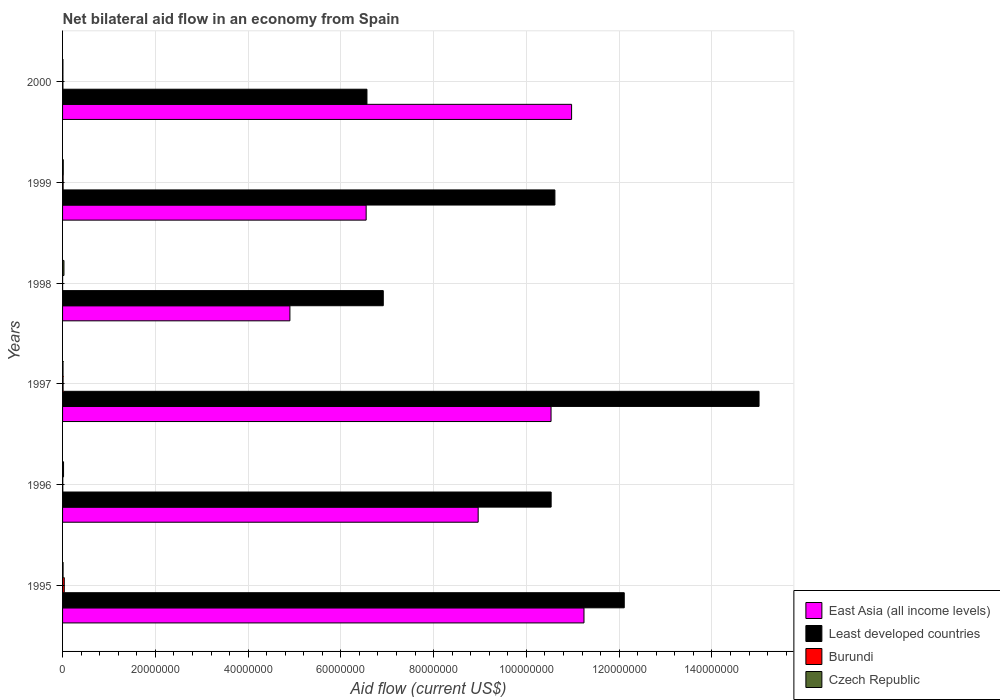How many different coloured bars are there?
Make the answer very short. 4. How many groups of bars are there?
Ensure brevity in your answer.  6. Are the number of bars per tick equal to the number of legend labels?
Make the answer very short. Yes. Are the number of bars on each tick of the Y-axis equal?
Offer a very short reply. Yes. How many bars are there on the 6th tick from the top?
Offer a very short reply. 4. How many bars are there on the 4th tick from the bottom?
Your answer should be compact. 4. In how many cases, is the number of bars for a given year not equal to the number of legend labels?
Make the answer very short. 0. What is the net bilateral aid flow in Burundi in 1996?
Your answer should be very brief. 5.00e+04. Across all years, what is the maximum net bilateral aid flow in East Asia (all income levels)?
Provide a short and direct response. 1.12e+08. In which year was the net bilateral aid flow in Czech Republic minimum?
Make the answer very short. 2000. What is the total net bilateral aid flow in Czech Republic in the graph?
Ensure brevity in your answer.  9.50e+05. What is the difference between the net bilateral aid flow in Czech Republic in 1996 and that in 1997?
Keep it short and to the point. 1.10e+05. What is the difference between the net bilateral aid flow in East Asia (all income levels) in 2000 and the net bilateral aid flow in Burundi in 1995?
Provide a succinct answer. 1.09e+08. What is the average net bilateral aid flow in East Asia (all income levels) per year?
Provide a short and direct response. 8.86e+07. In the year 1999, what is the difference between the net bilateral aid flow in Least developed countries and net bilateral aid flow in Czech Republic?
Provide a short and direct response. 1.06e+08. In how many years, is the net bilateral aid flow in Burundi greater than 124000000 US$?
Offer a terse response. 0. What is the ratio of the net bilateral aid flow in Least developed countries in 1995 to that in 1996?
Your answer should be very brief. 1.15. Is the net bilateral aid flow in Burundi in 1996 less than that in 1997?
Make the answer very short. Yes. Is the difference between the net bilateral aid flow in Least developed countries in 1995 and 2000 greater than the difference between the net bilateral aid flow in Czech Republic in 1995 and 2000?
Offer a very short reply. Yes. What is the difference between the highest and the second highest net bilateral aid flow in East Asia (all income levels)?
Your answer should be compact. 2.67e+06. What is the difference between the highest and the lowest net bilateral aid flow in Burundi?
Your response must be concise. 3.60e+05. In how many years, is the net bilateral aid flow in Least developed countries greater than the average net bilateral aid flow in Least developed countries taken over all years?
Make the answer very short. 4. Is the sum of the net bilateral aid flow in Burundi in 1997 and 1999 greater than the maximum net bilateral aid flow in East Asia (all income levels) across all years?
Provide a short and direct response. No. What does the 1st bar from the top in 1997 represents?
Provide a short and direct response. Czech Republic. What does the 2nd bar from the bottom in 1999 represents?
Offer a terse response. Least developed countries. How many years are there in the graph?
Give a very brief answer. 6. What is the difference between two consecutive major ticks on the X-axis?
Your answer should be very brief. 2.00e+07. Where does the legend appear in the graph?
Provide a short and direct response. Bottom right. How many legend labels are there?
Provide a succinct answer. 4. What is the title of the graph?
Your answer should be compact. Net bilateral aid flow in an economy from Spain. What is the label or title of the Y-axis?
Ensure brevity in your answer.  Years. What is the Aid flow (current US$) in East Asia (all income levels) in 1995?
Give a very brief answer. 1.12e+08. What is the Aid flow (current US$) of Least developed countries in 1995?
Make the answer very short. 1.21e+08. What is the Aid flow (current US$) in Burundi in 1995?
Offer a very short reply. 3.70e+05. What is the Aid flow (current US$) in East Asia (all income levels) in 1996?
Give a very brief answer. 8.96e+07. What is the Aid flow (current US$) of Least developed countries in 1996?
Offer a very short reply. 1.05e+08. What is the Aid flow (current US$) in Burundi in 1996?
Provide a short and direct response. 5.00e+04. What is the Aid flow (current US$) in East Asia (all income levels) in 1997?
Your response must be concise. 1.05e+08. What is the Aid flow (current US$) in Least developed countries in 1997?
Provide a short and direct response. 1.50e+08. What is the Aid flow (current US$) in Czech Republic in 1997?
Provide a short and direct response. 1.00e+05. What is the Aid flow (current US$) of East Asia (all income levels) in 1998?
Your response must be concise. 4.90e+07. What is the Aid flow (current US$) in Least developed countries in 1998?
Your response must be concise. 6.91e+07. What is the Aid flow (current US$) of Burundi in 1998?
Your answer should be very brief. 10000. What is the Aid flow (current US$) in Czech Republic in 1998?
Offer a very short reply. 3.00e+05. What is the Aid flow (current US$) of East Asia (all income levels) in 1999?
Offer a very short reply. 6.54e+07. What is the Aid flow (current US$) in Least developed countries in 1999?
Your answer should be compact. 1.06e+08. What is the Aid flow (current US$) of East Asia (all income levels) in 2000?
Give a very brief answer. 1.10e+08. What is the Aid flow (current US$) of Least developed countries in 2000?
Keep it short and to the point. 6.56e+07. Across all years, what is the maximum Aid flow (current US$) in East Asia (all income levels)?
Your answer should be compact. 1.12e+08. Across all years, what is the maximum Aid flow (current US$) in Least developed countries?
Your answer should be compact. 1.50e+08. Across all years, what is the maximum Aid flow (current US$) of Czech Republic?
Provide a succinct answer. 3.00e+05. Across all years, what is the minimum Aid flow (current US$) in East Asia (all income levels)?
Your answer should be very brief. 4.90e+07. Across all years, what is the minimum Aid flow (current US$) of Least developed countries?
Give a very brief answer. 6.56e+07. Across all years, what is the minimum Aid flow (current US$) in Czech Republic?
Provide a succinct answer. 8.00e+04. What is the total Aid flow (current US$) of East Asia (all income levels) in the graph?
Make the answer very short. 5.32e+08. What is the total Aid flow (current US$) of Least developed countries in the graph?
Provide a short and direct response. 6.17e+08. What is the total Aid flow (current US$) of Burundi in the graph?
Give a very brief answer. 7.40e+05. What is the total Aid flow (current US$) in Czech Republic in the graph?
Give a very brief answer. 9.50e+05. What is the difference between the Aid flow (current US$) of East Asia (all income levels) in 1995 and that in 1996?
Give a very brief answer. 2.28e+07. What is the difference between the Aid flow (current US$) in Least developed countries in 1995 and that in 1996?
Give a very brief answer. 1.58e+07. What is the difference between the Aid flow (current US$) of Burundi in 1995 and that in 1996?
Make the answer very short. 3.20e+05. What is the difference between the Aid flow (current US$) of Czech Republic in 1995 and that in 1996?
Make the answer very short. -1.00e+05. What is the difference between the Aid flow (current US$) in East Asia (all income levels) in 1995 and that in 1997?
Ensure brevity in your answer.  7.10e+06. What is the difference between the Aid flow (current US$) in Least developed countries in 1995 and that in 1997?
Offer a terse response. -2.91e+07. What is the difference between the Aid flow (current US$) in Czech Republic in 1995 and that in 1997?
Your answer should be compact. 10000. What is the difference between the Aid flow (current US$) in East Asia (all income levels) in 1995 and that in 1998?
Your answer should be compact. 6.34e+07. What is the difference between the Aid flow (current US$) of Least developed countries in 1995 and that in 1998?
Your answer should be very brief. 5.20e+07. What is the difference between the Aid flow (current US$) in Burundi in 1995 and that in 1998?
Provide a succinct answer. 3.60e+05. What is the difference between the Aid flow (current US$) of Czech Republic in 1995 and that in 1998?
Give a very brief answer. -1.90e+05. What is the difference between the Aid flow (current US$) in East Asia (all income levels) in 1995 and that in 1999?
Make the answer very short. 4.70e+07. What is the difference between the Aid flow (current US$) in Least developed countries in 1995 and that in 1999?
Offer a very short reply. 1.50e+07. What is the difference between the Aid flow (current US$) of Burundi in 1995 and that in 1999?
Provide a short and direct response. 2.50e+05. What is the difference between the Aid flow (current US$) in East Asia (all income levels) in 1995 and that in 2000?
Give a very brief answer. 2.67e+06. What is the difference between the Aid flow (current US$) in Least developed countries in 1995 and that in 2000?
Offer a terse response. 5.55e+07. What is the difference between the Aid flow (current US$) in Burundi in 1995 and that in 2000?
Provide a short and direct response. 2.90e+05. What is the difference between the Aid flow (current US$) in East Asia (all income levels) in 1996 and that in 1997?
Offer a very short reply. -1.57e+07. What is the difference between the Aid flow (current US$) in Least developed countries in 1996 and that in 1997?
Offer a very short reply. -4.48e+07. What is the difference between the Aid flow (current US$) of Burundi in 1996 and that in 1997?
Offer a terse response. -6.00e+04. What is the difference between the Aid flow (current US$) in East Asia (all income levels) in 1996 and that in 1998?
Offer a terse response. 4.06e+07. What is the difference between the Aid flow (current US$) in Least developed countries in 1996 and that in 1998?
Your response must be concise. 3.62e+07. What is the difference between the Aid flow (current US$) of Czech Republic in 1996 and that in 1998?
Provide a short and direct response. -9.00e+04. What is the difference between the Aid flow (current US$) in East Asia (all income levels) in 1996 and that in 1999?
Your answer should be very brief. 2.42e+07. What is the difference between the Aid flow (current US$) in Least developed countries in 1996 and that in 1999?
Your answer should be compact. -8.10e+05. What is the difference between the Aid flow (current US$) in Czech Republic in 1996 and that in 1999?
Offer a very short reply. 6.00e+04. What is the difference between the Aid flow (current US$) of East Asia (all income levels) in 1996 and that in 2000?
Make the answer very short. -2.01e+07. What is the difference between the Aid flow (current US$) of Least developed countries in 1996 and that in 2000?
Keep it short and to the point. 3.97e+07. What is the difference between the Aid flow (current US$) in Burundi in 1996 and that in 2000?
Give a very brief answer. -3.00e+04. What is the difference between the Aid flow (current US$) of Czech Republic in 1996 and that in 2000?
Your answer should be very brief. 1.30e+05. What is the difference between the Aid flow (current US$) of East Asia (all income levels) in 1997 and that in 1998?
Give a very brief answer. 5.63e+07. What is the difference between the Aid flow (current US$) of Least developed countries in 1997 and that in 1998?
Your answer should be compact. 8.10e+07. What is the difference between the Aid flow (current US$) of East Asia (all income levels) in 1997 and that in 1999?
Make the answer very short. 3.99e+07. What is the difference between the Aid flow (current US$) in Least developed countries in 1997 and that in 1999?
Offer a very short reply. 4.40e+07. What is the difference between the Aid flow (current US$) in Burundi in 1997 and that in 1999?
Your response must be concise. -10000. What is the difference between the Aid flow (current US$) in East Asia (all income levels) in 1997 and that in 2000?
Give a very brief answer. -4.43e+06. What is the difference between the Aid flow (current US$) of Least developed countries in 1997 and that in 2000?
Your answer should be compact. 8.45e+07. What is the difference between the Aid flow (current US$) of Burundi in 1997 and that in 2000?
Offer a terse response. 3.00e+04. What is the difference between the Aid flow (current US$) in East Asia (all income levels) in 1998 and that in 1999?
Make the answer very short. -1.64e+07. What is the difference between the Aid flow (current US$) of Least developed countries in 1998 and that in 1999?
Your response must be concise. -3.70e+07. What is the difference between the Aid flow (current US$) in Czech Republic in 1998 and that in 1999?
Your response must be concise. 1.50e+05. What is the difference between the Aid flow (current US$) in East Asia (all income levels) in 1998 and that in 2000?
Ensure brevity in your answer.  -6.07e+07. What is the difference between the Aid flow (current US$) of Least developed countries in 1998 and that in 2000?
Offer a terse response. 3.52e+06. What is the difference between the Aid flow (current US$) of Burundi in 1998 and that in 2000?
Your response must be concise. -7.00e+04. What is the difference between the Aid flow (current US$) in East Asia (all income levels) in 1999 and that in 2000?
Offer a very short reply. -4.43e+07. What is the difference between the Aid flow (current US$) in Least developed countries in 1999 and that in 2000?
Offer a terse response. 4.05e+07. What is the difference between the Aid flow (current US$) in Burundi in 1999 and that in 2000?
Ensure brevity in your answer.  4.00e+04. What is the difference between the Aid flow (current US$) of East Asia (all income levels) in 1995 and the Aid flow (current US$) of Least developed countries in 1996?
Your answer should be compact. 7.08e+06. What is the difference between the Aid flow (current US$) of East Asia (all income levels) in 1995 and the Aid flow (current US$) of Burundi in 1996?
Give a very brief answer. 1.12e+08. What is the difference between the Aid flow (current US$) of East Asia (all income levels) in 1995 and the Aid flow (current US$) of Czech Republic in 1996?
Ensure brevity in your answer.  1.12e+08. What is the difference between the Aid flow (current US$) of Least developed countries in 1995 and the Aid flow (current US$) of Burundi in 1996?
Provide a succinct answer. 1.21e+08. What is the difference between the Aid flow (current US$) of Least developed countries in 1995 and the Aid flow (current US$) of Czech Republic in 1996?
Provide a short and direct response. 1.21e+08. What is the difference between the Aid flow (current US$) of East Asia (all income levels) in 1995 and the Aid flow (current US$) of Least developed countries in 1997?
Keep it short and to the point. -3.77e+07. What is the difference between the Aid flow (current US$) in East Asia (all income levels) in 1995 and the Aid flow (current US$) in Burundi in 1997?
Your response must be concise. 1.12e+08. What is the difference between the Aid flow (current US$) in East Asia (all income levels) in 1995 and the Aid flow (current US$) in Czech Republic in 1997?
Give a very brief answer. 1.12e+08. What is the difference between the Aid flow (current US$) of Least developed countries in 1995 and the Aid flow (current US$) of Burundi in 1997?
Provide a succinct answer. 1.21e+08. What is the difference between the Aid flow (current US$) of Least developed countries in 1995 and the Aid flow (current US$) of Czech Republic in 1997?
Offer a terse response. 1.21e+08. What is the difference between the Aid flow (current US$) of East Asia (all income levels) in 1995 and the Aid flow (current US$) of Least developed countries in 1998?
Ensure brevity in your answer.  4.33e+07. What is the difference between the Aid flow (current US$) in East Asia (all income levels) in 1995 and the Aid flow (current US$) in Burundi in 1998?
Offer a terse response. 1.12e+08. What is the difference between the Aid flow (current US$) in East Asia (all income levels) in 1995 and the Aid flow (current US$) in Czech Republic in 1998?
Provide a succinct answer. 1.12e+08. What is the difference between the Aid flow (current US$) of Least developed countries in 1995 and the Aid flow (current US$) of Burundi in 1998?
Make the answer very short. 1.21e+08. What is the difference between the Aid flow (current US$) of Least developed countries in 1995 and the Aid flow (current US$) of Czech Republic in 1998?
Provide a succinct answer. 1.21e+08. What is the difference between the Aid flow (current US$) of Burundi in 1995 and the Aid flow (current US$) of Czech Republic in 1998?
Provide a succinct answer. 7.00e+04. What is the difference between the Aid flow (current US$) in East Asia (all income levels) in 1995 and the Aid flow (current US$) in Least developed countries in 1999?
Your answer should be compact. 6.27e+06. What is the difference between the Aid flow (current US$) in East Asia (all income levels) in 1995 and the Aid flow (current US$) in Burundi in 1999?
Offer a terse response. 1.12e+08. What is the difference between the Aid flow (current US$) in East Asia (all income levels) in 1995 and the Aid flow (current US$) in Czech Republic in 1999?
Keep it short and to the point. 1.12e+08. What is the difference between the Aid flow (current US$) of Least developed countries in 1995 and the Aid flow (current US$) of Burundi in 1999?
Make the answer very short. 1.21e+08. What is the difference between the Aid flow (current US$) of Least developed countries in 1995 and the Aid flow (current US$) of Czech Republic in 1999?
Keep it short and to the point. 1.21e+08. What is the difference between the Aid flow (current US$) of East Asia (all income levels) in 1995 and the Aid flow (current US$) of Least developed countries in 2000?
Your answer should be very brief. 4.68e+07. What is the difference between the Aid flow (current US$) of East Asia (all income levels) in 1995 and the Aid flow (current US$) of Burundi in 2000?
Ensure brevity in your answer.  1.12e+08. What is the difference between the Aid flow (current US$) of East Asia (all income levels) in 1995 and the Aid flow (current US$) of Czech Republic in 2000?
Your answer should be very brief. 1.12e+08. What is the difference between the Aid flow (current US$) of Least developed countries in 1995 and the Aid flow (current US$) of Burundi in 2000?
Make the answer very short. 1.21e+08. What is the difference between the Aid flow (current US$) of Least developed countries in 1995 and the Aid flow (current US$) of Czech Republic in 2000?
Your response must be concise. 1.21e+08. What is the difference between the Aid flow (current US$) in Burundi in 1995 and the Aid flow (current US$) in Czech Republic in 2000?
Your answer should be compact. 2.90e+05. What is the difference between the Aid flow (current US$) of East Asia (all income levels) in 1996 and the Aid flow (current US$) of Least developed countries in 1997?
Your answer should be very brief. -6.06e+07. What is the difference between the Aid flow (current US$) in East Asia (all income levels) in 1996 and the Aid flow (current US$) in Burundi in 1997?
Ensure brevity in your answer.  8.95e+07. What is the difference between the Aid flow (current US$) of East Asia (all income levels) in 1996 and the Aid flow (current US$) of Czech Republic in 1997?
Keep it short and to the point. 8.95e+07. What is the difference between the Aid flow (current US$) of Least developed countries in 1996 and the Aid flow (current US$) of Burundi in 1997?
Offer a terse response. 1.05e+08. What is the difference between the Aid flow (current US$) in Least developed countries in 1996 and the Aid flow (current US$) in Czech Republic in 1997?
Provide a succinct answer. 1.05e+08. What is the difference between the Aid flow (current US$) in Burundi in 1996 and the Aid flow (current US$) in Czech Republic in 1997?
Provide a succinct answer. -5.00e+04. What is the difference between the Aid flow (current US$) of East Asia (all income levels) in 1996 and the Aid flow (current US$) of Least developed countries in 1998?
Give a very brief answer. 2.05e+07. What is the difference between the Aid flow (current US$) in East Asia (all income levels) in 1996 and the Aid flow (current US$) in Burundi in 1998?
Make the answer very short. 8.96e+07. What is the difference between the Aid flow (current US$) in East Asia (all income levels) in 1996 and the Aid flow (current US$) in Czech Republic in 1998?
Ensure brevity in your answer.  8.93e+07. What is the difference between the Aid flow (current US$) of Least developed countries in 1996 and the Aid flow (current US$) of Burundi in 1998?
Your response must be concise. 1.05e+08. What is the difference between the Aid flow (current US$) in Least developed countries in 1996 and the Aid flow (current US$) in Czech Republic in 1998?
Ensure brevity in your answer.  1.05e+08. What is the difference between the Aid flow (current US$) of East Asia (all income levels) in 1996 and the Aid flow (current US$) of Least developed countries in 1999?
Provide a short and direct response. -1.65e+07. What is the difference between the Aid flow (current US$) in East Asia (all income levels) in 1996 and the Aid flow (current US$) in Burundi in 1999?
Keep it short and to the point. 8.95e+07. What is the difference between the Aid flow (current US$) of East Asia (all income levels) in 1996 and the Aid flow (current US$) of Czech Republic in 1999?
Make the answer very short. 8.94e+07. What is the difference between the Aid flow (current US$) of Least developed countries in 1996 and the Aid flow (current US$) of Burundi in 1999?
Your answer should be compact. 1.05e+08. What is the difference between the Aid flow (current US$) of Least developed countries in 1996 and the Aid flow (current US$) of Czech Republic in 1999?
Give a very brief answer. 1.05e+08. What is the difference between the Aid flow (current US$) in Burundi in 1996 and the Aid flow (current US$) in Czech Republic in 1999?
Give a very brief answer. -1.00e+05. What is the difference between the Aid flow (current US$) in East Asia (all income levels) in 1996 and the Aid flow (current US$) in Least developed countries in 2000?
Keep it short and to the point. 2.40e+07. What is the difference between the Aid flow (current US$) in East Asia (all income levels) in 1996 and the Aid flow (current US$) in Burundi in 2000?
Your response must be concise. 8.95e+07. What is the difference between the Aid flow (current US$) in East Asia (all income levels) in 1996 and the Aid flow (current US$) in Czech Republic in 2000?
Provide a short and direct response. 8.95e+07. What is the difference between the Aid flow (current US$) of Least developed countries in 1996 and the Aid flow (current US$) of Burundi in 2000?
Your response must be concise. 1.05e+08. What is the difference between the Aid flow (current US$) of Least developed countries in 1996 and the Aid flow (current US$) of Czech Republic in 2000?
Give a very brief answer. 1.05e+08. What is the difference between the Aid flow (current US$) in Burundi in 1996 and the Aid flow (current US$) in Czech Republic in 2000?
Ensure brevity in your answer.  -3.00e+04. What is the difference between the Aid flow (current US$) of East Asia (all income levels) in 1997 and the Aid flow (current US$) of Least developed countries in 1998?
Offer a very short reply. 3.62e+07. What is the difference between the Aid flow (current US$) of East Asia (all income levels) in 1997 and the Aid flow (current US$) of Burundi in 1998?
Offer a terse response. 1.05e+08. What is the difference between the Aid flow (current US$) in East Asia (all income levels) in 1997 and the Aid flow (current US$) in Czech Republic in 1998?
Offer a terse response. 1.05e+08. What is the difference between the Aid flow (current US$) of Least developed countries in 1997 and the Aid flow (current US$) of Burundi in 1998?
Provide a short and direct response. 1.50e+08. What is the difference between the Aid flow (current US$) of Least developed countries in 1997 and the Aid flow (current US$) of Czech Republic in 1998?
Ensure brevity in your answer.  1.50e+08. What is the difference between the Aid flow (current US$) of East Asia (all income levels) in 1997 and the Aid flow (current US$) of Least developed countries in 1999?
Your response must be concise. -8.30e+05. What is the difference between the Aid flow (current US$) of East Asia (all income levels) in 1997 and the Aid flow (current US$) of Burundi in 1999?
Make the answer very short. 1.05e+08. What is the difference between the Aid flow (current US$) in East Asia (all income levels) in 1997 and the Aid flow (current US$) in Czech Republic in 1999?
Your response must be concise. 1.05e+08. What is the difference between the Aid flow (current US$) in Least developed countries in 1997 and the Aid flow (current US$) in Burundi in 1999?
Ensure brevity in your answer.  1.50e+08. What is the difference between the Aid flow (current US$) in Least developed countries in 1997 and the Aid flow (current US$) in Czech Republic in 1999?
Make the answer very short. 1.50e+08. What is the difference between the Aid flow (current US$) in East Asia (all income levels) in 1997 and the Aid flow (current US$) in Least developed countries in 2000?
Give a very brief answer. 3.97e+07. What is the difference between the Aid flow (current US$) of East Asia (all income levels) in 1997 and the Aid flow (current US$) of Burundi in 2000?
Make the answer very short. 1.05e+08. What is the difference between the Aid flow (current US$) in East Asia (all income levels) in 1997 and the Aid flow (current US$) in Czech Republic in 2000?
Ensure brevity in your answer.  1.05e+08. What is the difference between the Aid flow (current US$) of Least developed countries in 1997 and the Aid flow (current US$) of Burundi in 2000?
Offer a very short reply. 1.50e+08. What is the difference between the Aid flow (current US$) of Least developed countries in 1997 and the Aid flow (current US$) of Czech Republic in 2000?
Your response must be concise. 1.50e+08. What is the difference between the Aid flow (current US$) of Burundi in 1997 and the Aid flow (current US$) of Czech Republic in 2000?
Make the answer very short. 3.00e+04. What is the difference between the Aid flow (current US$) in East Asia (all income levels) in 1998 and the Aid flow (current US$) in Least developed countries in 1999?
Your answer should be very brief. -5.71e+07. What is the difference between the Aid flow (current US$) in East Asia (all income levels) in 1998 and the Aid flow (current US$) in Burundi in 1999?
Offer a terse response. 4.89e+07. What is the difference between the Aid flow (current US$) of East Asia (all income levels) in 1998 and the Aid flow (current US$) of Czech Republic in 1999?
Offer a terse response. 4.89e+07. What is the difference between the Aid flow (current US$) in Least developed countries in 1998 and the Aid flow (current US$) in Burundi in 1999?
Ensure brevity in your answer.  6.90e+07. What is the difference between the Aid flow (current US$) in Least developed countries in 1998 and the Aid flow (current US$) in Czech Republic in 1999?
Offer a very short reply. 6.90e+07. What is the difference between the Aid flow (current US$) of East Asia (all income levels) in 1998 and the Aid flow (current US$) of Least developed countries in 2000?
Keep it short and to the point. -1.66e+07. What is the difference between the Aid flow (current US$) in East Asia (all income levels) in 1998 and the Aid flow (current US$) in Burundi in 2000?
Provide a short and direct response. 4.89e+07. What is the difference between the Aid flow (current US$) in East Asia (all income levels) in 1998 and the Aid flow (current US$) in Czech Republic in 2000?
Your answer should be very brief. 4.89e+07. What is the difference between the Aid flow (current US$) of Least developed countries in 1998 and the Aid flow (current US$) of Burundi in 2000?
Your response must be concise. 6.91e+07. What is the difference between the Aid flow (current US$) in Least developed countries in 1998 and the Aid flow (current US$) in Czech Republic in 2000?
Your answer should be very brief. 6.91e+07. What is the difference between the Aid flow (current US$) of East Asia (all income levels) in 1999 and the Aid flow (current US$) of Least developed countries in 2000?
Your answer should be very brief. -1.70e+05. What is the difference between the Aid flow (current US$) of East Asia (all income levels) in 1999 and the Aid flow (current US$) of Burundi in 2000?
Your response must be concise. 6.54e+07. What is the difference between the Aid flow (current US$) of East Asia (all income levels) in 1999 and the Aid flow (current US$) of Czech Republic in 2000?
Offer a terse response. 6.54e+07. What is the difference between the Aid flow (current US$) in Least developed countries in 1999 and the Aid flow (current US$) in Burundi in 2000?
Keep it short and to the point. 1.06e+08. What is the difference between the Aid flow (current US$) in Least developed countries in 1999 and the Aid flow (current US$) in Czech Republic in 2000?
Your answer should be compact. 1.06e+08. What is the average Aid flow (current US$) of East Asia (all income levels) per year?
Keep it short and to the point. 8.86e+07. What is the average Aid flow (current US$) in Least developed countries per year?
Give a very brief answer. 1.03e+08. What is the average Aid flow (current US$) of Burundi per year?
Ensure brevity in your answer.  1.23e+05. What is the average Aid flow (current US$) of Czech Republic per year?
Make the answer very short. 1.58e+05. In the year 1995, what is the difference between the Aid flow (current US$) in East Asia (all income levels) and Aid flow (current US$) in Least developed countries?
Your answer should be very brief. -8.68e+06. In the year 1995, what is the difference between the Aid flow (current US$) in East Asia (all income levels) and Aid flow (current US$) in Burundi?
Keep it short and to the point. 1.12e+08. In the year 1995, what is the difference between the Aid flow (current US$) in East Asia (all income levels) and Aid flow (current US$) in Czech Republic?
Offer a terse response. 1.12e+08. In the year 1995, what is the difference between the Aid flow (current US$) in Least developed countries and Aid flow (current US$) in Burundi?
Offer a terse response. 1.21e+08. In the year 1995, what is the difference between the Aid flow (current US$) of Least developed countries and Aid flow (current US$) of Czech Republic?
Your response must be concise. 1.21e+08. In the year 1995, what is the difference between the Aid flow (current US$) of Burundi and Aid flow (current US$) of Czech Republic?
Ensure brevity in your answer.  2.60e+05. In the year 1996, what is the difference between the Aid flow (current US$) in East Asia (all income levels) and Aid flow (current US$) in Least developed countries?
Provide a succinct answer. -1.57e+07. In the year 1996, what is the difference between the Aid flow (current US$) of East Asia (all income levels) and Aid flow (current US$) of Burundi?
Your answer should be compact. 8.96e+07. In the year 1996, what is the difference between the Aid flow (current US$) in East Asia (all income levels) and Aid flow (current US$) in Czech Republic?
Make the answer very short. 8.94e+07. In the year 1996, what is the difference between the Aid flow (current US$) of Least developed countries and Aid flow (current US$) of Burundi?
Keep it short and to the point. 1.05e+08. In the year 1996, what is the difference between the Aid flow (current US$) of Least developed countries and Aid flow (current US$) of Czech Republic?
Offer a terse response. 1.05e+08. In the year 1996, what is the difference between the Aid flow (current US$) of Burundi and Aid flow (current US$) of Czech Republic?
Ensure brevity in your answer.  -1.60e+05. In the year 1997, what is the difference between the Aid flow (current US$) in East Asia (all income levels) and Aid flow (current US$) in Least developed countries?
Your answer should be compact. -4.48e+07. In the year 1997, what is the difference between the Aid flow (current US$) in East Asia (all income levels) and Aid flow (current US$) in Burundi?
Provide a succinct answer. 1.05e+08. In the year 1997, what is the difference between the Aid flow (current US$) of East Asia (all income levels) and Aid flow (current US$) of Czech Republic?
Provide a succinct answer. 1.05e+08. In the year 1997, what is the difference between the Aid flow (current US$) in Least developed countries and Aid flow (current US$) in Burundi?
Ensure brevity in your answer.  1.50e+08. In the year 1997, what is the difference between the Aid flow (current US$) of Least developed countries and Aid flow (current US$) of Czech Republic?
Offer a terse response. 1.50e+08. In the year 1997, what is the difference between the Aid flow (current US$) of Burundi and Aid flow (current US$) of Czech Republic?
Provide a succinct answer. 10000. In the year 1998, what is the difference between the Aid flow (current US$) of East Asia (all income levels) and Aid flow (current US$) of Least developed countries?
Provide a succinct answer. -2.01e+07. In the year 1998, what is the difference between the Aid flow (current US$) of East Asia (all income levels) and Aid flow (current US$) of Burundi?
Offer a very short reply. 4.90e+07. In the year 1998, what is the difference between the Aid flow (current US$) of East Asia (all income levels) and Aid flow (current US$) of Czech Republic?
Your response must be concise. 4.87e+07. In the year 1998, what is the difference between the Aid flow (current US$) of Least developed countries and Aid flow (current US$) of Burundi?
Keep it short and to the point. 6.91e+07. In the year 1998, what is the difference between the Aid flow (current US$) of Least developed countries and Aid flow (current US$) of Czech Republic?
Provide a short and direct response. 6.88e+07. In the year 1999, what is the difference between the Aid flow (current US$) of East Asia (all income levels) and Aid flow (current US$) of Least developed countries?
Your answer should be very brief. -4.07e+07. In the year 1999, what is the difference between the Aid flow (current US$) of East Asia (all income levels) and Aid flow (current US$) of Burundi?
Keep it short and to the point. 6.53e+07. In the year 1999, what is the difference between the Aid flow (current US$) in East Asia (all income levels) and Aid flow (current US$) in Czech Republic?
Provide a succinct answer. 6.53e+07. In the year 1999, what is the difference between the Aid flow (current US$) in Least developed countries and Aid flow (current US$) in Burundi?
Your answer should be very brief. 1.06e+08. In the year 1999, what is the difference between the Aid flow (current US$) in Least developed countries and Aid flow (current US$) in Czech Republic?
Make the answer very short. 1.06e+08. In the year 1999, what is the difference between the Aid flow (current US$) in Burundi and Aid flow (current US$) in Czech Republic?
Offer a terse response. -3.00e+04. In the year 2000, what is the difference between the Aid flow (current US$) in East Asia (all income levels) and Aid flow (current US$) in Least developed countries?
Provide a succinct answer. 4.41e+07. In the year 2000, what is the difference between the Aid flow (current US$) of East Asia (all income levels) and Aid flow (current US$) of Burundi?
Make the answer very short. 1.10e+08. In the year 2000, what is the difference between the Aid flow (current US$) of East Asia (all income levels) and Aid flow (current US$) of Czech Republic?
Make the answer very short. 1.10e+08. In the year 2000, what is the difference between the Aid flow (current US$) in Least developed countries and Aid flow (current US$) in Burundi?
Your answer should be compact. 6.55e+07. In the year 2000, what is the difference between the Aid flow (current US$) in Least developed countries and Aid flow (current US$) in Czech Republic?
Keep it short and to the point. 6.55e+07. In the year 2000, what is the difference between the Aid flow (current US$) in Burundi and Aid flow (current US$) in Czech Republic?
Give a very brief answer. 0. What is the ratio of the Aid flow (current US$) of East Asia (all income levels) in 1995 to that in 1996?
Keep it short and to the point. 1.25. What is the ratio of the Aid flow (current US$) in Least developed countries in 1995 to that in 1996?
Offer a very short reply. 1.15. What is the ratio of the Aid flow (current US$) in Burundi in 1995 to that in 1996?
Keep it short and to the point. 7.4. What is the ratio of the Aid flow (current US$) of Czech Republic in 1995 to that in 1996?
Offer a very short reply. 0.52. What is the ratio of the Aid flow (current US$) of East Asia (all income levels) in 1995 to that in 1997?
Your response must be concise. 1.07. What is the ratio of the Aid flow (current US$) in Least developed countries in 1995 to that in 1997?
Provide a short and direct response. 0.81. What is the ratio of the Aid flow (current US$) of Burundi in 1995 to that in 1997?
Give a very brief answer. 3.36. What is the ratio of the Aid flow (current US$) in East Asia (all income levels) in 1995 to that in 1998?
Offer a terse response. 2.29. What is the ratio of the Aid flow (current US$) in Least developed countries in 1995 to that in 1998?
Make the answer very short. 1.75. What is the ratio of the Aid flow (current US$) of Burundi in 1995 to that in 1998?
Provide a short and direct response. 37. What is the ratio of the Aid flow (current US$) in Czech Republic in 1995 to that in 1998?
Provide a succinct answer. 0.37. What is the ratio of the Aid flow (current US$) in East Asia (all income levels) in 1995 to that in 1999?
Provide a short and direct response. 1.72. What is the ratio of the Aid flow (current US$) of Least developed countries in 1995 to that in 1999?
Offer a very short reply. 1.14. What is the ratio of the Aid flow (current US$) of Burundi in 1995 to that in 1999?
Provide a short and direct response. 3.08. What is the ratio of the Aid flow (current US$) in Czech Republic in 1995 to that in 1999?
Offer a terse response. 0.73. What is the ratio of the Aid flow (current US$) in East Asia (all income levels) in 1995 to that in 2000?
Provide a short and direct response. 1.02. What is the ratio of the Aid flow (current US$) of Least developed countries in 1995 to that in 2000?
Keep it short and to the point. 1.85. What is the ratio of the Aid flow (current US$) of Burundi in 1995 to that in 2000?
Offer a terse response. 4.62. What is the ratio of the Aid flow (current US$) in Czech Republic in 1995 to that in 2000?
Keep it short and to the point. 1.38. What is the ratio of the Aid flow (current US$) in East Asia (all income levels) in 1996 to that in 1997?
Offer a terse response. 0.85. What is the ratio of the Aid flow (current US$) of Least developed countries in 1996 to that in 1997?
Your answer should be very brief. 0.7. What is the ratio of the Aid flow (current US$) in Burundi in 1996 to that in 1997?
Your answer should be very brief. 0.45. What is the ratio of the Aid flow (current US$) in Czech Republic in 1996 to that in 1997?
Offer a terse response. 2.1. What is the ratio of the Aid flow (current US$) in East Asia (all income levels) in 1996 to that in 1998?
Your answer should be compact. 1.83. What is the ratio of the Aid flow (current US$) in Least developed countries in 1996 to that in 1998?
Ensure brevity in your answer.  1.52. What is the ratio of the Aid flow (current US$) of Burundi in 1996 to that in 1998?
Your answer should be very brief. 5. What is the ratio of the Aid flow (current US$) of East Asia (all income levels) in 1996 to that in 1999?
Provide a succinct answer. 1.37. What is the ratio of the Aid flow (current US$) of Burundi in 1996 to that in 1999?
Offer a very short reply. 0.42. What is the ratio of the Aid flow (current US$) in East Asia (all income levels) in 1996 to that in 2000?
Your answer should be compact. 0.82. What is the ratio of the Aid flow (current US$) in Least developed countries in 1996 to that in 2000?
Offer a terse response. 1.61. What is the ratio of the Aid flow (current US$) of Czech Republic in 1996 to that in 2000?
Keep it short and to the point. 2.62. What is the ratio of the Aid flow (current US$) in East Asia (all income levels) in 1997 to that in 1998?
Your response must be concise. 2.15. What is the ratio of the Aid flow (current US$) in Least developed countries in 1997 to that in 1998?
Provide a short and direct response. 2.17. What is the ratio of the Aid flow (current US$) of East Asia (all income levels) in 1997 to that in 1999?
Keep it short and to the point. 1.61. What is the ratio of the Aid flow (current US$) of Least developed countries in 1997 to that in 1999?
Your answer should be compact. 1.41. What is the ratio of the Aid flow (current US$) of Burundi in 1997 to that in 1999?
Ensure brevity in your answer.  0.92. What is the ratio of the Aid flow (current US$) of Czech Republic in 1997 to that in 1999?
Make the answer very short. 0.67. What is the ratio of the Aid flow (current US$) in East Asia (all income levels) in 1997 to that in 2000?
Provide a short and direct response. 0.96. What is the ratio of the Aid flow (current US$) of Least developed countries in 1997 to that in 2000?
Your response must be concise. 2.29. What is the ratio of the Aid flow (current US$) in Burundi in 1997 to that in 2000?
Provide a short and direct response. 1.38. What is the ratio of the Aid flow (current US$) of Czech Republic in 1997 to that in 2000?
Give a very brief answer. 1.25. What is the ratio of the Aid flow (current US$) in East Asia (all income levels) in 1998 to that in 1999?
Provide a succinct answer. 0.75. What is the ratio of the Aid flow (current US$) in Least developed countries in 1998 to that in 1999?
Your answer should be compact. 0.65. What is the ratio of the Aid flow (current US$) of Burundi in 1998 to that in 1999?
Your answer should be compact. 0.08. What is the ratio of the Aid flow (current US$) of East Asia (all income levels) in 1998 to that in 2000?
Make the answer very short. 0.45. What is the ratio of the Aid flow (current US$) in Least developed countries in 1998 to that in 2000?
Keep it short and to the point. 1.05. What is the ratio of the Aid flow (current US$) in Burundi in 1998 to that in 2000?
Provide a short and direct response. 0.12. What is the ratio of the Aid flow (current US$) of Czech Republic in 1998 to that in 2000?
Provide a short and direct response. 3.75. What is the ratio of the Aid flow (current US$) of East Asia (all income levels) in 1999 to that in 2000?
Make the answer very short. 0.6. What is the ratio of the Aid flow (current US$) of Least developed countries in 1999 to that in 2000?
Offer a terse response. 1.62. What is the ratio of the Aid flow (current US$) of Czech Republic in 1999 to that in 2000?
Offer a very short reply. 1.88. What is the difference between the highest and the second highest Aid flow (current US$) in East Asia (all income levels)?
Offer a terse response. 2.67e+06. What is the difference between the highest and the second highest Aid flow (current US$) in Least developed countries?
Give a very brief answer. 2.91e+07. What is the difference between the highest and the second highest Aid flow (current US$) in Czech Republic?
Your answer should be compact. 9.00e+04. What is the difference between the highest and the lowest Aid flow (current US$) of East Asia (all income levels)?
Offer a very short reply. 6.34e+07. What is the difference between the highest and the lowest Aid flow (current US$) in Least developed countries?
Your answer should be compact. 8.45e+07. What is the difference between the highest and the lowest Aid flow (current US$) of Czech Republic?
Ensure brevity in your answer.  2.20e+05. 